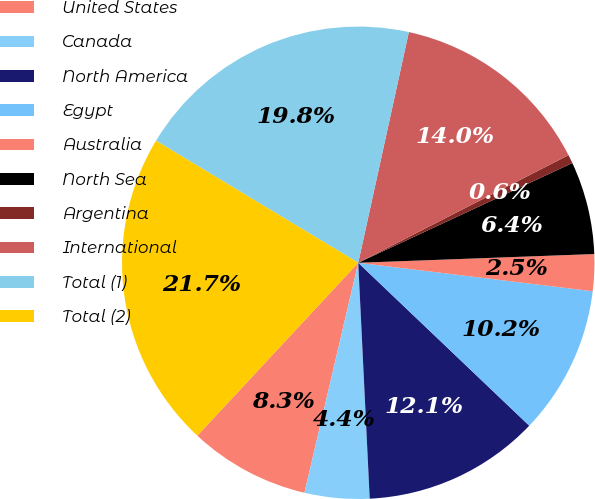Convert chart to OTSL. <chart><loc_0><loc_0><loc_500><loc_500><pie_chart><fcel>United States<fcel>Canada<fcel>North America<fcel>Egypt<fcel>Australia<fcel>North Sea<fcel>Argentina<fcel>International<fcel>Total (1)<fcel>Total (2)<nl><fcel>8.27%<fcel>4.43%<fcel>12.11%<fcel>10.19%<fcel>2.51%<fcel>6.35%<fcel>0.59%<fcel>14.03%<fcel>19.79%<fcel>21.71%<nl></chart> 